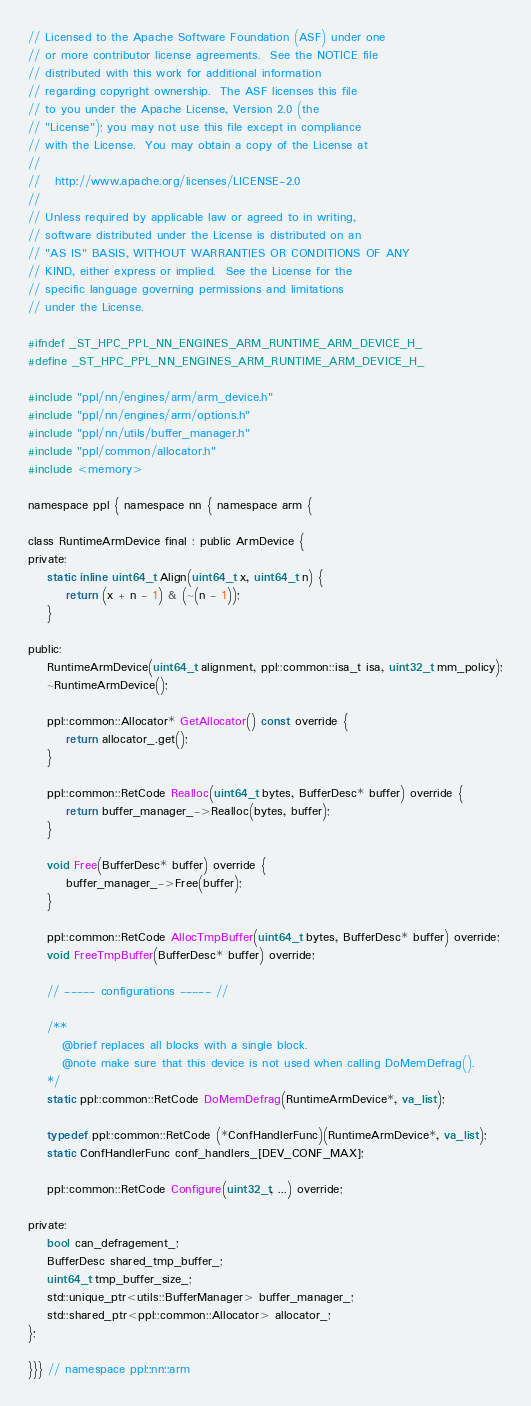<code> <loc_0><loc_0><loc_500><loc_500><_C_>// Licensed to the Apache Software Foundation (ASF) under one
// or more contributor license agreements.  See the NOTICE file
// distributed with this work for additional information
// regarding copyright ownership.  The ASF licenses this file
// to you under the Apache License, Version 2.0 (the
// "License"); you may not use this file except in compliance
// with the License.  You may obtain a copy of the License at
//
//   http://www.apache.org/licenses/LICENSE-2.0
//
// Unless required by applicable law or agreed to in writing,
// software distributed under the License is distributed on an
// "AS IS" BASIS, WITHOUT WARRANTIES OR CONDITIONS OF ANY
// KIND, either express or implied.  See the License for the
// specific language governing permissions and limitations
// under the License.

#ifndef _ST_HPC_PPL_NN_ENGINES_ARM_RUNTIME_ARM_DEVICE_H_
#define _ST_HPC_PPL_NN_ENGINES_ARM_RUNTIME_ARM_DEVICE_H_

#include "ppl/nn/engines/arm/arm_device.h"
#include "ppl/nn/engines/arm/options.h"
#include "ppl/nn/utils/buffer_manager.h"
#include "ppl/common/allocator.h"
#include <memory>

namespace ppl { namespace nn { namespace arm {

class RuntimeArmDevice final : public ArmDevice {
private:
    static inline uint64_t Align(uint64_t x, uint64_t n) {
        return (x + n - 1) & (~(n - 1));
    }

public:
    RuntimeArmDevice(uint64_t alignment, ppl::common::isa_t isa, uint32_t mm_policy);
    ~RuntimeArmDevice();

    ppl::common::Allocator* GetAllocator() const override {
        return allocator_.get();
    }

    ppl::common::RetCode Realloc(uint64_t bytes, BufferDesc* buffer) override {
        return buffer_manager_->Realloc(bytes, buffer);
    }

    void Free(BufferDesc* buffer) override {
        buffer_manager_->Free(buffer);
    }

    ppl::common::RetCode AllocTmpBuffer(uint64_t bytes, BufferDesc* buffer) override;
    void FreeTmpBuffer(BufferDesc* buffer) override;

    // ----- configurations ----- //

    /**
       @brief replaces all blocks with a single block.
       @note make sure that this device is not used when calling DoMemDefrag().
    */
    static ppl::common::RetCode DoMemDefrag(RuntimeArmDevice*, va_list);

    typedef ppl::common::RetCode (*ConfHandlerFunc)(RuntimeArmDevice*, va_list);
    static ConfHandlerFunc conf_handlers_[DEV_CONF_MAX];

    ppl::common::RetCode Configure(uint32_t, ...) override;

private:
    bool can_defragement_;
    BufferDesc shared_tmp_buffer_;
    uint64_t tmp_buffer_size_;
    std::unique_ptr<utils::BufferManager> buffer_manager_;
    std::shared_ptr<ppl::common::Allocator> allocator_;
};

}}} // namespace ppl::nn::arm
</code> 